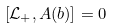Convert formula to latex. <formula><loc_0><loc_0><loc_500><loc_500>\left [ \mathcal { L } _ { + } , A ( b ) \right ] = 0</formula> 